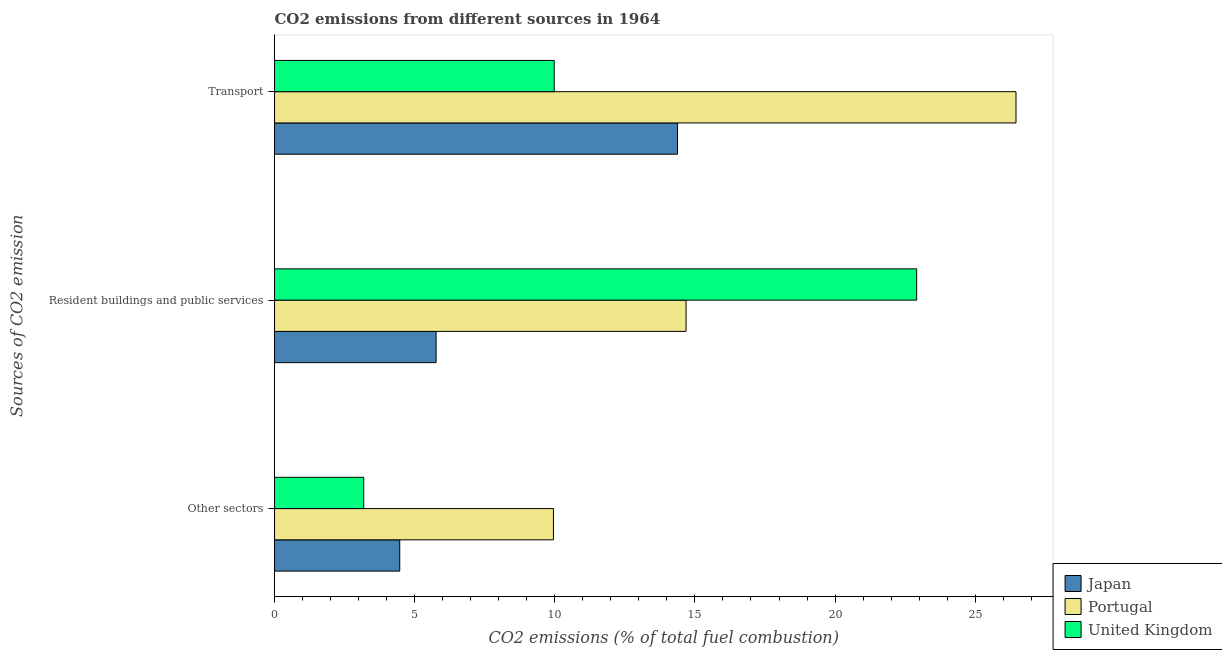How many groups of bars are there?
Give a very brief answer. 3. Are the number of bars per tick equal to the number of legend labels?
Provide a succinct answer. Yes. What is the label of the 3rd group of bars from the top?
Offer a very short reply. Other sectors. What is the percentage of co2 emissions from other sectors in United Kingdom?
Give a very brief answer. 3.18. Across all countries, what is the maximum percentage of co2 emissions from transport?
Provide a succinct answer. 26.46. Across all countries, what is the minimum percentage of co2 emissions from resident buildings and public services?
Ensure brevity in your answer.  5.77. What is the total percentage of co2 emissions from resident buildings and public services in the graph?
Your answer should be compact. 43.36. What is the difference between the percentage of co2 emissions from transport in Japan and that in United Kingdom?
Keep it short and to the point. 4.4. What is the difference between the percentage of co2 emissions from transport in Japan and the percentage of co2 emissions from other sectors in United Kingdom?
Your answer should be very brief. 11.2. What is the average percentage of co2 emissions from transport per country?
Offer a very short reply. 16.94. What is the difference between the percentage of co2 emissions from other sectors and percentage of co2 emissions from resident buildings and public services in United Kingdom?
Ensure brevity in your answer.  -19.73. In how many countries, is the percentage of co2 emissions from transport greater than 7 %?
Provide a succinct answer. 3. What is the ratio of the percentage of co2 emissions from transport in United Kingdom to that in Japan?
Give a very brief answer. 0.69. Is the percentage of co2 emissions from resident buildings and public services in United Kingdom less than that in Portugal?
Ensure brevity in your answer.  No. What is the difference between the highest and the second highest percentage of co2 emissions from resident buildings and public services?
Your answer should be very brief. 8.23. What is the difference between the highest and the lowest percentage of co2 emissions from other sectors?
Offer a terse response. 6.77. Is it the case that in every country, the sum of the percentage of co2 emissions from other sectors and percentage of co2 emissions from resident buildings and public services is greater than the percentage of co2 emissions from transport?
Your response must be concise. No. Are all the bars in the graph horizontal?
Your answer should be very brief. Yes. How many countries are there in the graph?
Provide a short and direct response. 3. How many legend labels are there?
Your answer should be compact. 3. What is the title of the graph?
Your answer should be compact. CO2 emissions from different sources in 1964. Does "Algeria" appear as one of the legend labels in the graph?
Make the answer very short. No. What is the label or title of the X-axis?
Give a very brief answer. CO2 emissions (% of total fuel combustion). What is the label or title of the Y-axis?
Your answer should be compact. Sources of CO2 emission. What is the CO2 emissions (% of total fuel combustion) of Japan in Other sectors?
Provide a short and direct response. 4.47. What is the CO2 emissions (% of total fuel combustion) of Portugal in Other sectors?
Offer a terse response. 9.95. What is the CO2 emissions (% of total fuel combustion) in United Kingdom in Other sectors?
Provide a succinct answer. 3.18. What is the CO2 emissions (% of total fuel combustion) of Japan in Resident buildings and public services?
Your answer should be compact. 5.77. What is the CO2 emissions (% of total fuel combustion) in Portugal in Resident buildings and public services?
Provide a short and direct response. 14.68. What is the CO2 emissions (% of total fuel combustion) in United Kingdom in Resident buildings and public services?
Give a very brief answer. 22.91. What is the CO2 emissions (% of total fuel combustion) of Japan in Transport?
Provide a short and direct response. 14.38. What is the CO2 emissions (% of total fuel combustion) in Portugal in Transport?
Keep it short and to the point. 26.46. What is the CO2 emissions (% of total fuel combustion) in United Kingdom in Transport?
Ensure brevity in your answer.  9.98. Across all Sources of CO2 emission, what is the maximum CO2 emissions (% of total fuel combustion) in Japan?
Provide a succinct answer. 14.38. Across all Sources of CO2 emission, what is the maximum CO2 emissions (% of total fuel combustion) in Portugal?
Give a very brief answer. 26.46. Across all Sources of CO2 emission, what is the maximum CO2 emissions (% of total fuel combustion) of United Kingdom?
Your answer should be very brief. 22.91. Across all Sources of CO2 emission, what is the minimum CO2 emissions (% of total fuel combustion) of Japan?
Ensure brevity in your answer.  4.47. Across all Sources of CO2 emission, what is the minimum CO2 emissions (% of total fuel combustion) in Portugal?
Give a very brief answer. 9.95. Across all Sources of CO2 emission, what is the minimum CO2 emissions (% of total fuel combustion) in United Kingdom?
Keep it short and to the point. 3.18. What is the total CO2 emissions (% of total fuel combustion) of Japan in the graph?
Offer a very short reply. 24.61. What is the total CO2 emissions (% of total fuel combustion) of Portugal in the graph?
Keep it short and to the point. 51.09. What is the total CO2 emissions (% of total fuel combustion) in United Kingdom in the graph?
Your answer should be compact. 36.07. What is the difference between the CO2 emissions (% of total fuel combustion) of Japan in Other sectors and that in Resident buildings and public services?
Give a very brief answer. -1.3. What is the difference between the CO2 emissions (% of total fuel combustion) of Portugal in Other sectors and that in Resident buildings and public services?
Offer a very short reply. -4.73. What is the difference between the CO2 emissions (% of total fuel combustion) in United Kingdom in Other sectors and that in Resident buildings and public services?
Make the answer very short. -19.73. What is the difference between the CO2 emissions (% of total fuel combustion) of Japan in Other sectors and that in Transport?
Your response must be concise. -9.91. What is the difference between the CO2 emissions (% of total fuel combustion) of Portugal in Other sectors and that in Transport?
Ensure brevity in your answer.  -16.5. What is the difference between the CO2 emissions (% of total fuel combustion) in United Kingdom in Other sectors and that in Transport?
Your response must be concise. -6.8. What is the difference between the CO2 emissions (% of total fuel combustion) in Japan in Resident buildings and public services and that in Transport?
Provide a succinct answer. -8.61. What is the difference between the CO2 emissions (% of total fuel combustion) of Portugal in Resident buildings and public services and that in Transport?
Your answer should be compact. -11.77. What is the difference between the CO2 emissions (% of total fuel combustion) in United Kingdom in Resident buildings and public services and that in Transport?
Your answer should be very brief. 12.93. What is the difference between the CO2 emissions (% of total fuel combustion) in Japan in Other sectors and the CO2 emissions (% of total fuel combustion) in Portugal in Resident buildings and public services?
Give a very brief answer. -10.22. What is the difference between the CO2 emissions (% of total fuel combustion) of Japan in Other sectors and the CO2 emissions (% of total fuel combustion) of United Kingdom in Resident buildings and public services?
Ensure brevity in your answer.  -18.44. What is the difference between the CO2 emissions (% of total fuel combustion) in Portugal in Other sectors and the CO2 emissions (% of total fuel combustion) in United Kingdom in Resident buildings and public services?
Provide a short and direct response. -12.96. What is the difference between the CO2 emissions (% of total fuel combustion) of Japan in Other sectors and the CO2 emissions (% of total fuel combustion) of Portugal in Transport?
Provide a succinct answer. -21.99. What is the difference between the CO2 emissions (% of total fuel combustion) in Japan in Other sectors and the CO2 emissions (% of total fuel combustion) in United Kingdom in Transport?
Offer a terse response. -5.51. What is the difference between the CO2 emissions (% of total fuel combustion) of Portugal in Other sectors and the CO2 emissions (% of total fuel combustion) of United Kingdom in Transport?
Offer a terse response. -0.03. What is the difference between the CO2 emissions (% of total fuel combustion) in Japan in Resident buildings and public services and the CO2 emissions (% of total fuel combustion) in Portugal in Transport?
Provide a succinct answer. -20.69. What is the difference between the CO2 emissions (% of total fuel combustion) of Japan in Resident buildings and public services and the CO2 emissions (% of total fuel combustion) of United Kingdom in Transport?
Keep it short and to the point. -4.21. What is the difference between the CO2 emissions (% of total fuel combustion) of Portugal in Resident buildings and public services and the CO2 emissions (% of total fuel combustion) of United Kingdom in Transport?
Provide a succinct answer. 4.71. What is the average CO2 emissions (% of total fuel combustion) in Japan per Sources of CO2 emission?
Keep it short and to the point. 8.2. What is the average CO2 emissions (% of total fuel combustion) of Portugal per Sources of CO2 emission?
Provide a succinct answer. 17.03. What is the average CO2 emissions (% of total fuel combustion) of United Kingdom per Sources of CO2 emission?
Provide a succinct answer. 12.02. What is the difference between the CO2 emissions (% of total fuel combustion) in Japan and CO2 emissions (% of total fuel combustion) in Portugal in Other sectors?
Your answer should be compact. -5.48. What is the difference between the CO2 emissions (% of total fuel combustion) of Japan and CO2 emissions (% of total fuel combustion) of United Kingdom in Other sectors?
Your answer should be compact. 1.29. What is the difference between the CO2 emissions (% of total fuel combustion) in Portugal and CO2 emissions (% of total fuel combustion) in United Kingdom in Other sectors?
Ensure brevity in your answer.  6.77. What is the difference between the CO2 emissions (% of total fuel combustion) in Japan and CO2 emissions (% of total fuel combustion) in Portugal in Resident buildings and public services?
Make the answer very short. -8.92. What is the difference between the CO2 emissions (% of total fuel combustion) of Japan and CO2 emissions (% of total fuel combustion) of United Kingdom in Resident buildings and public services?
Make the answer very short. -17.15. What is the difference between the CO2 emissions (% of total fuel combustion) of Portugal and CO2 emissions (% of total fuel combustion) of United Kingdom in Resident buildings and public services?
Your answer should be compact. -8.23. What is the difference between the CO2 emissions (% of total fuel combustion) in Japan and CO2 emissions (% of total fuel combustion) in Portugal in Transport?
Keep it short and to the point. -12.08. What is the difference between the CO2 emissions (% of total fuel combustion) in Japan and CO2 emissions (% of total fuel combustion) in United Kingdom in Transport?
Offer a terse response. 4.4. What is the difference between the CO2 emissions (% of total fuel combustion) in Portugal and CO2 emissions (% of total fuel combustion) in United Kingdom in Transport?
Provide a succinct answer. 16.48. What is the ratio of the CO2 emissions (% of total fuel combustion) of Japan in Other sectors to that in Resident buildings and public services?
Give a very brief answer. 0.77. What is the ratio of the CO2 emissions (% of total fuel combustion) in Portugal in Other sectors to that in Resident buildings and public services?
Provide a succinct answer. 0.68. What is the ratio of the CO2 emissions (% of total fuel combustion) of United Kingdom in Other sectors to that in Resident buildings and public services?
Offer a very short reply. 0.14. What is the ratio of the CO2 emissions (% of total fuel combustion) of Japan in Other sectors to that in Transport?
Keep it short and to the point. 0.31. What is the ratio of the CO2 emissions (% of total fuel combustion) of Portugal in Other sectors to that in Transport?
Offer a terse response. 0.38. What is the ratio of the CO2 emissions (% of total fuel combustion) in United Kingdom in Other sectors to that in Transport?
Keep it short and to the point. 0.32. What is the ratio of the CO2 emissions (% of total fuel combustion) of Japan in Resident buildings and public services to that in Transport?
Your answer should be compact. 0.4. What is the ratio of the CO2 emissions (% of total fuel combustion) in Portugal in Resident buildings and public services to that in Transport?
Offer a terse response. 0.56. What is the ratio of the CO2 emissions (% of total fuel combustion) in United Kingdom in Resident buildings and public services to that in Transport?
Offer a terse response. 2.3. What is the difference between the highest and the second highest CO2 emissions (% of total fuel combustion) of Japan?
Your answer should be compact. 8.61. What is the difference between the highest and the second highest CO2 emissions (% of total fuel combustion) in Portugal?
Offer a very short reply. 11.77. What is the difference between the highest and the second highest CO2 emissions (% of total fuel combustion) of United Kingdom?
Make the answer very short. 12.93. What is the difference between the highest and the lowest CO2 emissions (% of total fuel combustion) in Japan?
Give a very brief answer. 9.91. What is the difference between the highest and the lowest CO2 emissions (% of total fuel combustion) in Portugal?
Ensure brevity in your answer.  16.5. What is the difference between the highest and the lowest CO2 emissions (% of total fuel combustion) of United Kingdom?
Your response must be concise. 19.73. 